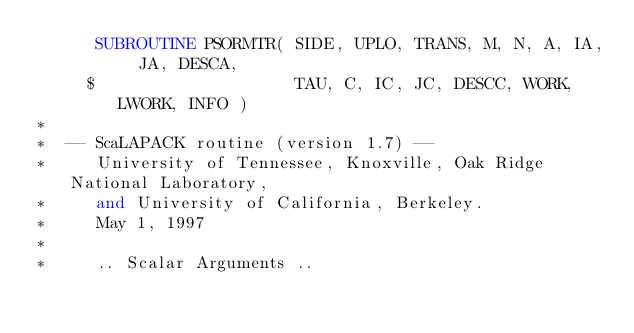<code> <loc_0><loc_0><loc_500><loc_500><_FORTRAN_>      SUBROUTINE PSORMTR( SIDE, UPLO, TRANS, M, N, A, IA, JA, DESCA,
     $                    TAU, C, IC, JC, DESCC, WORK, LWORK, INFO )
*
*  -- ScaLAPACK routine (version 1.7) --
*     University of Tennessee, Knoxville, Oak Ridge National Laboratory,
*     and University of California, Berkeley.
*     May 1, 1997
*
*     .. Scalar Arguments ..</code> 